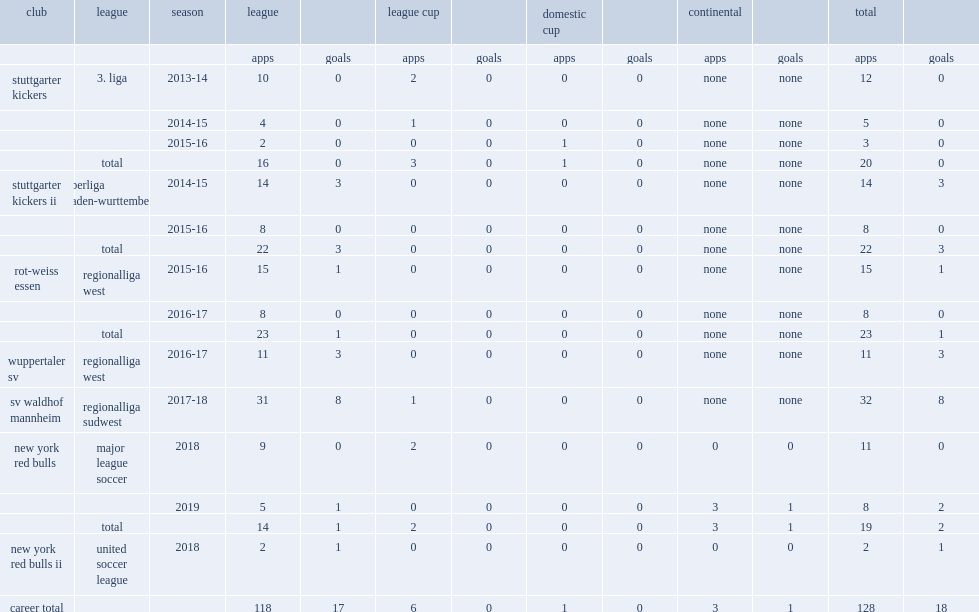Which club did andreas ivan play for in 2018? New york red bulls. 